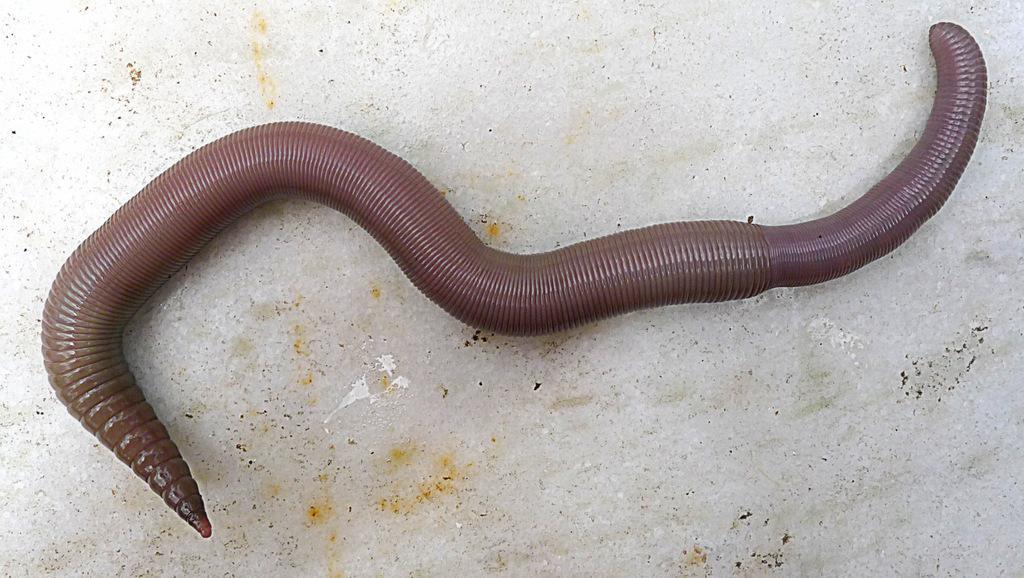Describe this image in one or two sentences. This image consists of a earth worm. It is in brown color. At the bottom, there is a floor. 